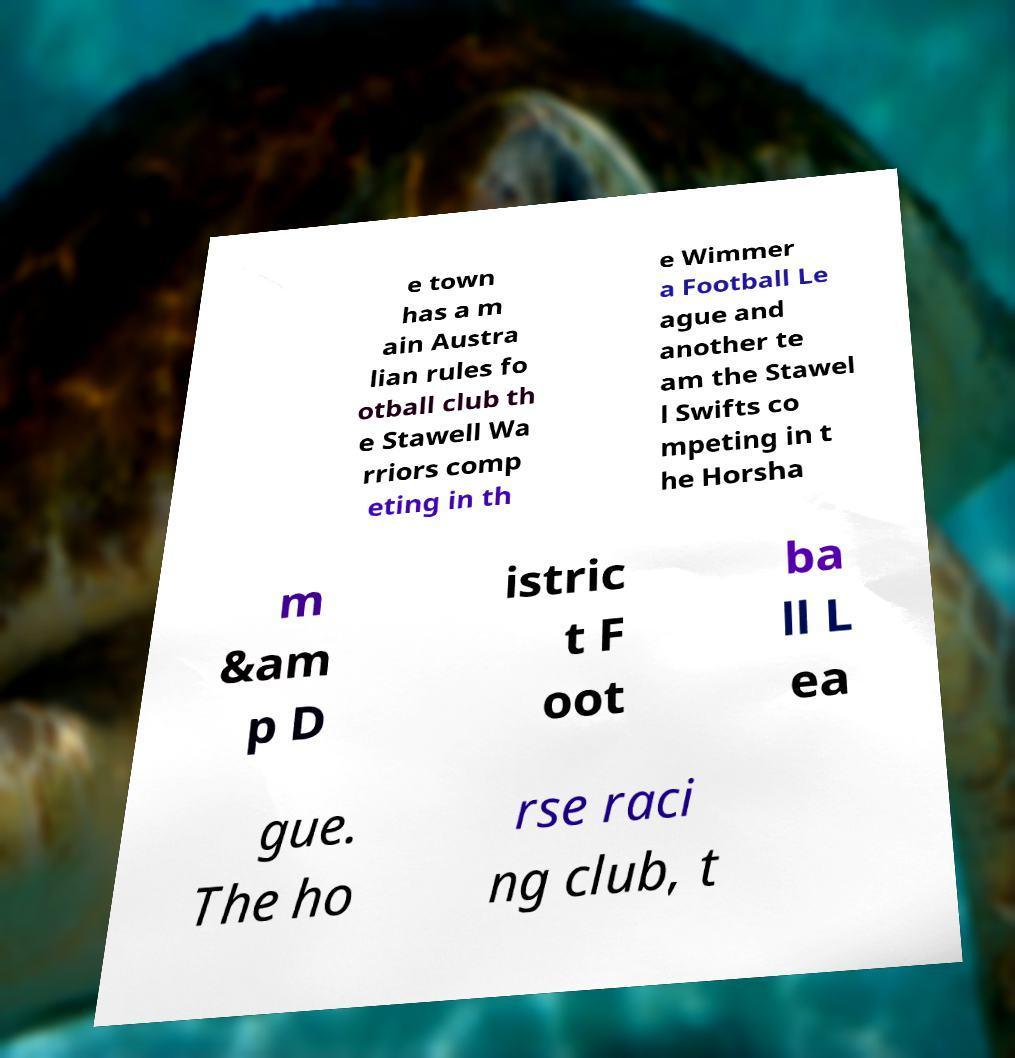What messages or text are displayed in this image? I need them in a readable, typed format. e town has a m ain Austra lian rules fo otball club th e Stawell Wa rriors comp eting in th e Wimmer a Football Le ague and another te am the Stawel l Swifts co mpeting in t he Horsha m &am p D istric t F oot ba ll L ea gue. The ho rse raci ng club, t 